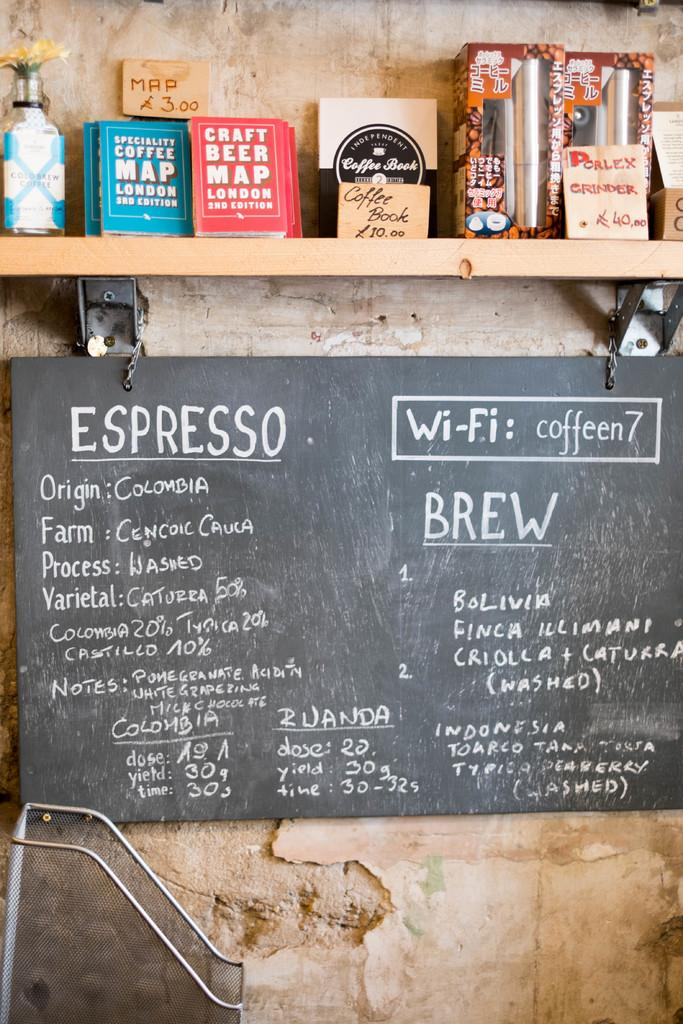<image>
Render a clear and concise summary of the photo. The coffee shop has a sign about the type of Espresso they serve. 